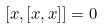Convert formula to latex. <formula><loc_0><loc_0><loc_500><loc_500>[ x , [ x , x ] ] = 0</formula> 